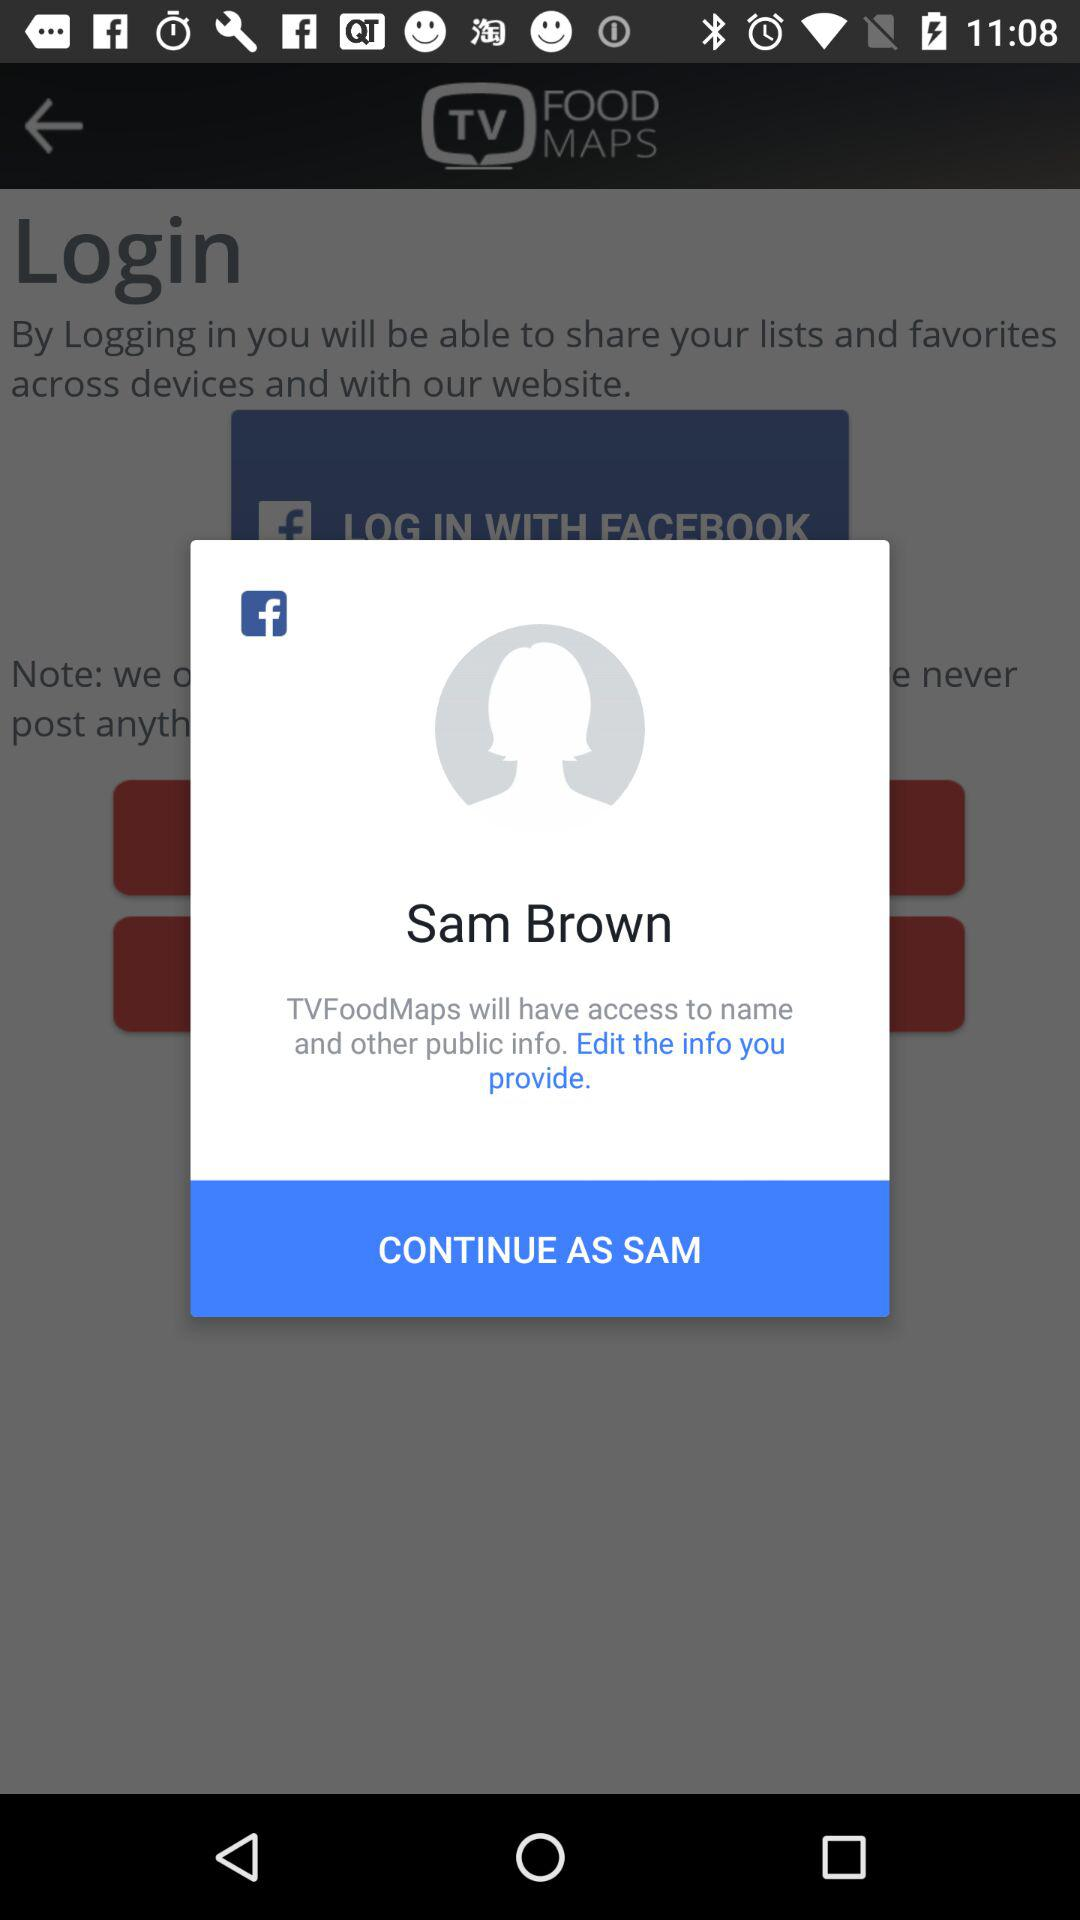What is the user's name? The user's name is Sam Brown. 